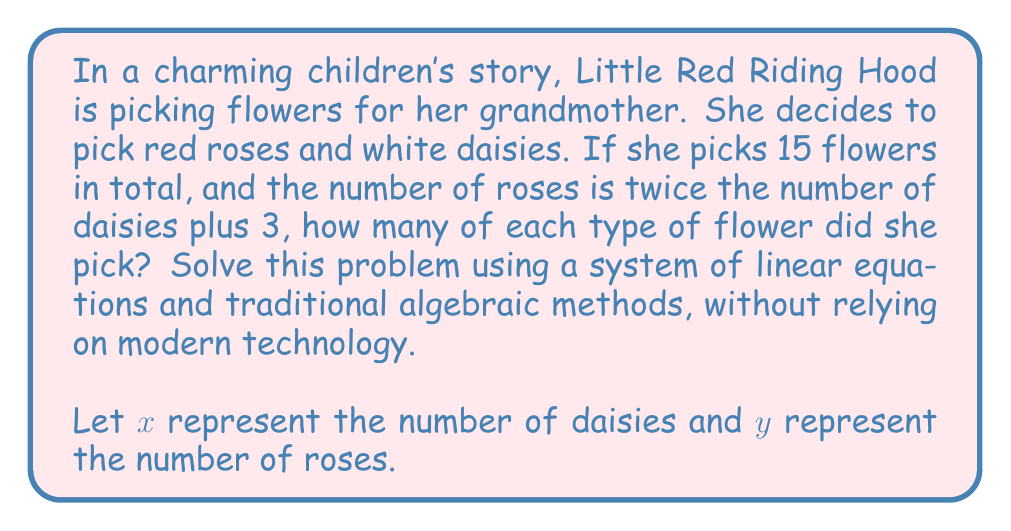Can you solve this math problem? To solve this problem using traditional algebraic methods, we'll set up a system of linear equations and use substitution.

Step 1: Set up the system of equations
From the given information, we can create two equations:

1. The total number of flowers: $x + y = 15$
2. The relationship between roses and daisies: $y = 2x + 3$

Our system of equations is:
$$\begin{cases}
x + y = 15 \\
y = 2x + 3
\end{cases}$$

Step 2: Substitute the second equation into the first
Replace $y$ in the first equation with $2x + 3$:
$$x + (2x + 3) = 15$$

Step 3: Solve for $x$
$$\begin{align}
x + 2x + 3 &= 15 \\
3x + 3 &= 15 \\
3x &= 12 \\
x &= 4
\end{align}$$

Step 4: Find $y$ by substituting $x = 4$ into the equation $y = 2x + 3$
$$\begin{align}
y &= 2(4) + 3 \\
y &= 8 + 3 \\
y &= 11
\end{align}$$

Step 5: Check the solution
Verify that $x = 4$ and $y = 11$ satisfy both original equations:

1. $x + y = 15$: $4 + 11 = 15$ (True)
2. $y = 2x + 3$: $11 = 2(4) + 3$ (True)

Therefore, Little Red Riding Hood picked 4 daisies and 11 roses.
Answer: Little Red Riding Hood picked 4 daisies ($x = 4$) and 11 roses ($y = 11$). 